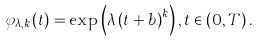<formula> <loc_0><loc_0><loc_500><loc_500>\varphi _ { \lambda , k } \left ( t \right ) = \exp \left ( \lambda \left ( t + b \right ) ^ { k } \right ) , t \in \left ( 0 , T \right ) .</formula> 